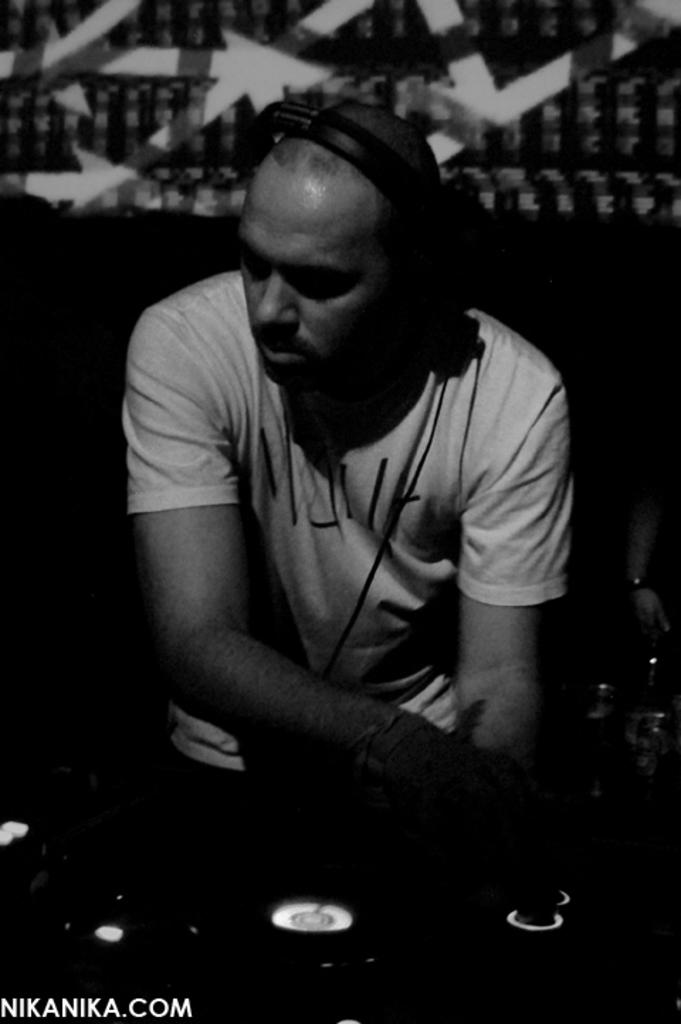Who is present in the image? There is a man in the image. What is the man wearing? The man is wearing a white t-shirt. What can be seen on the man's head? The man has headphones or a headset on his head. What is the man doing in the image? The man is mixing songs. What type of powder is visible on the roof in the image? There is no roof or powder present in the image. 